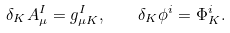Convert formula to latex. <formula><loc_0><loc_0><loc_500><loc_500>\delta _ { K } A _ { \mu } ^ { I } = g _ { \mu K } ^ { I } , \quad \delta _ { K } \phi ^ { i } = \Phi ^ { i } _ { K } .</formula> 